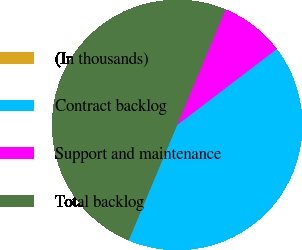Convert chart. <chart><loc_0><loc_0><loc_500><loc_500><pie_chart><fcel>(In thousands)<fcel>Contract backlog<fcel>Support and maintenance<fcel>Total backlog<nl><fcel>0.03%<fcel>41.67%<fcel>8.31%<fcel>49.98%<nl></chart> 